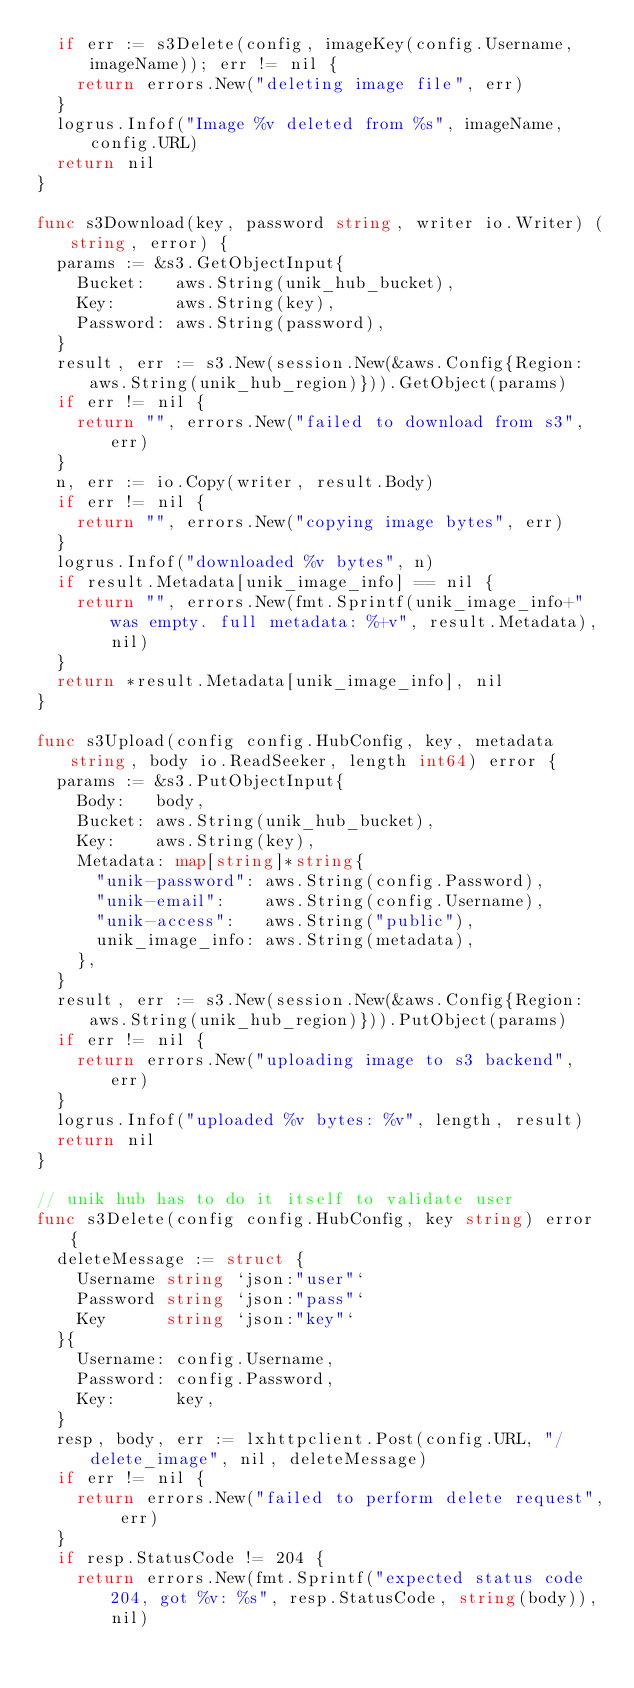<code> <loc_0><loc_0><loc_500><loc_500><_Go_>	if err := s3Delete(config, imageKey(config.Username, imageName)); err != nil {
		return errors.New("deleting image file", err)
	}
	logrus.Infof("Image %v deleted from %s", imageName, config.URL)
	return nil
}

func s3Download(key, password string, writer io.Writer) (string, error) {
	params := &s3.GetObjectInput{
		Bucket:   aws.String(unik_hub_bucket),
		Key:      aws.String(key),
		Password: aws.String(password),
	}
	result, err := s3.New(session.New(&aws.Config{Region: aws.String(unik_hub_region)})).GetObject(params)
	if err != nil {
		return "", errors.New("failed to download from s3", err)
	}
	n, err := io.Copy(writer, result.Body)
	if err != nil {
		return "", errors.New("copying image bytes", err)
	}
	logrus.Infof("downloaded %v bytes", n)
	if result.Metadata[unik_image_info] == nil {
		return "", errors.New(fmt.Sprintf(unik_image_info+" was empty. full metadata: %+v", result.Metadata), nil)
	}
	return *result.Metadata[unik_image_info], nil
}

func s3Upload(config config.HubConfig, key, metadata string, body io.ReadSeeker, length int64) error {
	params := &s3.PutObjectInput{
		Body:   body,
		Bucket: aws.String(unik_hub_bucket),
		Key:    aws.String(key),
		Metadata: map[string]*string{
			"unik-password": aws.String(config.Password),
			"unik-email":    aws.String(config.Username),
			"unik-access":   aws.String("public"),
			unik_image_info: aws.String(metadata),
		},
	}
	result, err := s3.New(session.New(&aws.Config{Region: aws.String(unik_hub_region)})).PutObject(params)
	if err != nil {
		return errors.New("uploading image to s3 backend", err)
	}
	logrus.Infof("uploaded %v bytes: %v", length, result)
	return nil
}

// unik hub has to do it itself to validate user
func s3Delete(config config.HubConfig, key string) error {
	deleteMessage := struct {
		Username string `json:"user"`
		Password string `json:"pass"`
		Key      string `json:"key"`
	}{
		Username: config.Username,
		Password: config.Password,
		Key:      key,
	}
	resp, body, err := lxhttpclient.Post(config.URL, "/delete_image", nil, deleteMessage)
	if err != nil {
		return errors.New("failed to perform delete request", err)
	}
	if resp.StatusCode != 204 {
		return errors.New(fmt.Sprintf("expected status code 204, got %v: %s", resp.StatusCode, string(body)), nil)</code> 